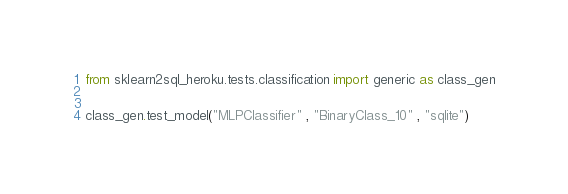<code> <loc_0><loc_0><loc_500><loc_500><_Python_>from sklearn2sql_heroku.tests.classification import generic as class_gen


class_gen.test_model("MLPClassifier" , "BinaryClass_10" , "sqlite")
</code> 